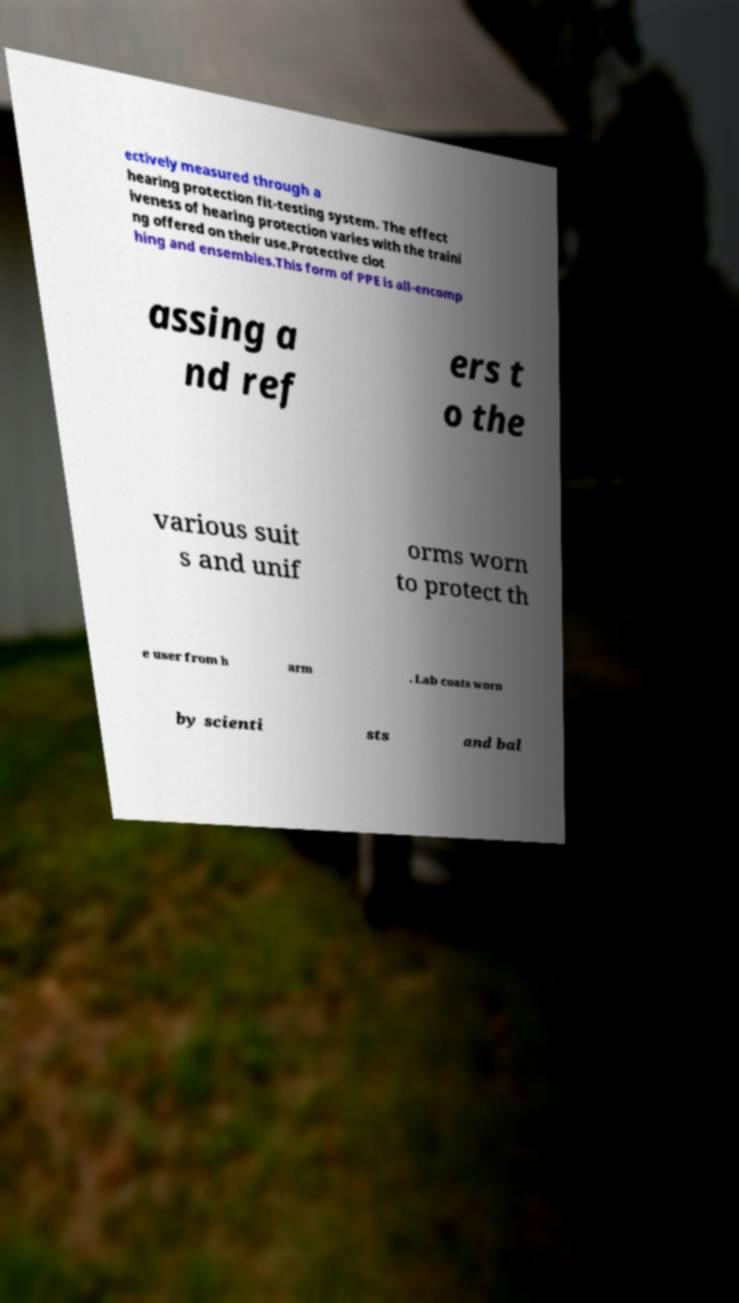Can you accurately transcribe the text from the provided image for me? ectively measured through a hearing protection fit-testing system. The effect iveness of hearing protection varies with the traini ng offered on their use.Protective clot hing and ensembles.This form of PPE is all-encomp assing a nd ref ers t o the various suit s and unif orms worn to protect th e user from h arm . Lab coats worn by scienti sts and bal 